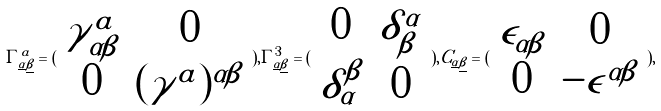<formula> <loc_0><loc_0><loc_500><loc_500>\Gamma _ { \underline { \alpha } \underline { \beta } } ^ { a } = ( \begin{array} { c c } \gamma _ { \alpha \beta } ^ { a } & 0 \\ 0 & ( \gamma ^ { a } ) ^ { \alpha \beta } \end{array} ) , \Gamma _ { \underline { \alpha } \underline { \beta } } ^ { 3 } = ( \begin{array} { c c } 0 & \delta _ { \beta } ^ { \alpha } \\ \delta _ { \alpha } ^ { \beta } & 0 \end{array} ) , C _ { \underline { \alpha } \underline { \beta } } = ( \begin{array} { c c } \epsilon _ { \alpha \beta } & 0 \\ 0 & - \epsilon ^ { \alpha \beta } \end{array} ) ,</formula> 